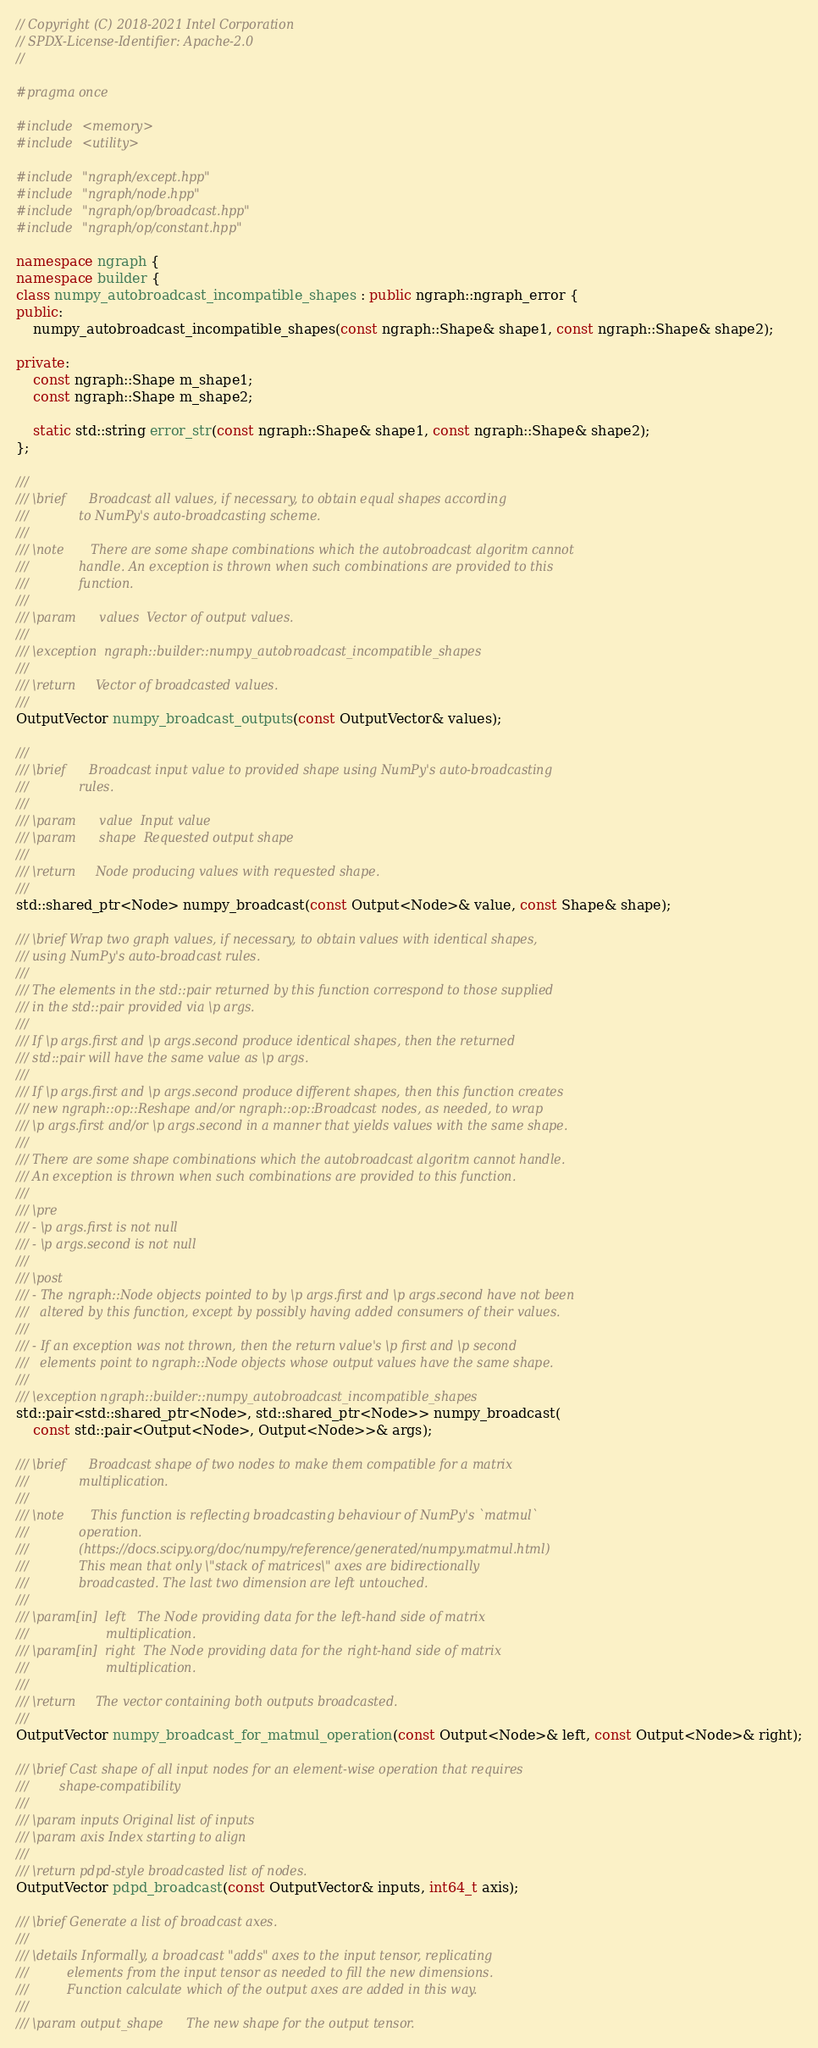<code> <loc_0><loc_0><loc_500><loc_500><_C++_>// Copyright (C) 2018-2021 Intel Corporation
// SPDX-License-Identifier: Apache-2.0
//

#pragma once

#include <memory>
#include <utility>

#include "ngraph/except.hpp"
#include "ngraph/node.hpp"
#include "ngraph/op/broadcast.hpp"
#include "ngraph/op/constant.hpp"

namespace ngraph {
namespace builder {
class numpy_autobroadcast_incompatible_shapes : public ngraph::ngraph_error {
public:
    numpy_autobroadcast_incompatible_shapes(const ngraph::Shape& shape1, const ngraph::Shape& shape2);

private:
    const ngraph::Shape m_shape1;
    const ngraph::Shape m_shape2;

    static std::string error_str(const ngraph::Shape& shape1, const ngraph::Shape& shape2);
};

///
/// \brief      Broadcast all values, if necessary, to obtain equal shapes according
///             to NumPy's auto-broadcasting scheme.
///
/// \note       There are some shape combinations which the autobroadcast algoritm cannot
///             handle. An exception is thrown when such combinations are provided to this
///             function.
///
/// \param      values  Vector of output values.
///
/// \exception  ngraph::builder::numpy_autobroadcast_incompatible_shapes
///
/// \return     Vector of broadcasted values.
///
OutputVector numpy_broadcast_outputs(const OutputVector& values);

///
/// \brief      Broadcast input value to provided shape using NumPy's auto-broadcasting
///             rules.
///
/// \param      value  Input value
/// \param      shape  Requested output shape
///
/// \return     Node producing values with requested shape.
///
std::shared_ptr<Node> numpy_broadcast(const Output<Node>& value, const Shape& shape);

/// \brief Wrap two graph values, if necessary, to obtain values with identical shapes,
/// using NumPy's auto-broadcast rules.
///
/// The elements in the std::pair returned by this function correspond to those supplied
/// in the std::pair provided via \p args.
///
/// If \p args.first and \p args.second produce identical shapes, then the returned
/// std::pair will have the same value as \p args.
///
/// If \p args.first and \p args.second produce different shapes, then this function creates
/// new ngraph::op::Reshape and/or ngraph::op::Broadcast nodes, as needed, to wrap
/// \p args.first and/or \p args.second in a manner that yields values with the same shape.
///
/// There are some shape combinations which the autobroadcast algoritm cannot handle.
/// An exception is thrown when such combinations are provided to this function.
///
/// \pre
/// - \p args.first is not null
/// - \p args.second is not null
///
/// \post
/// - The ngraph::Node objects pointed to by \p args.first and \p args.second have not been
///   altered by this function, except by possibly having added consumers of their values.
///
/// - If an exception was not thrown, then the return value's \p first and \p second
///   elements point to ngraph::Node objects whose output values have the same shape.
///
/// \exception ngraph::builder::numpy_autobroadcast_incompatible_shapes
std::pair<std::shared_ptr<Node>, std::shared_ptr<Node>> numpy_broadcast(
    const std::pair<Output<Node>, Output<Node>>& args);

/// \brief      Broadcast shape of two nodes to make them compatible for a matrix
///             multiplication.
///
/// \note       This function is reflecting broadcasting behaviour of NumPy's `matmul`
///             operation.
///             (https://docs.scipy.org/doc/numpy/reference/generated/numpy.matmul.html)
///             This mean that only \"stack of matrices\" axes are bidirectionally
///             broadcasted. The last two dimension are left untouched.
///
/// \param[in]  left   The Node providing data for the left-hand side of matrix
///                    multiplication.
/// \param[in]  right  The Node providing data for the right-hand side of matrix
///                    multiplication.
///
/// \return     The vector containing both outputs broadcasted.
///
OutputVector numpy_broadcast_for_matmul_operation(const Output<Node>& left, const Output<Node>& right);

/// \brief Cast shape of all input nodes for an element-wise operation that requires
///        shape-compatibility
///
/// \param inputs Original list of inputs
/// \param axis Index starting to align
///
/// \return pdpd-style broadcasted list of nodes.
OutputVector pdpd_broadcast(const OutputVector& inputs, int64_t axis);

/// \brief Generate a list of broadcast axes.
///
/// \details Informally, a broadcast "adds" axes to the input tensor, replicating
///          elements from the input tensor as needed to fill the new dimensions.
///          Function calculate which of the output axes are added in this way.
///
/// \param output_shape      The new shape for the output tensor.</code> 